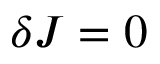Convert formula to latex. <formula><loc_0><loc_0><loc_500><loc_500>\delta J = 0</formula> 